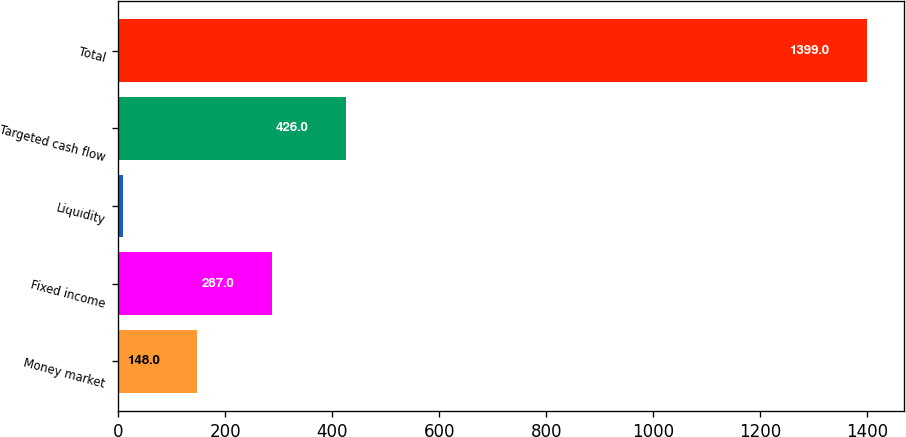Convert chart. <chart><loc_0><loc_0><loc_500><loc_500><bar_chart><fcel>Money market<fcel>Fixed income<fcel>Liquidity<fcel>Targeted cash flow<fcel>Total<nl><fcel>148<fcel>287<fcel>9<fcel>426<fcel>1399<nl></chart> 